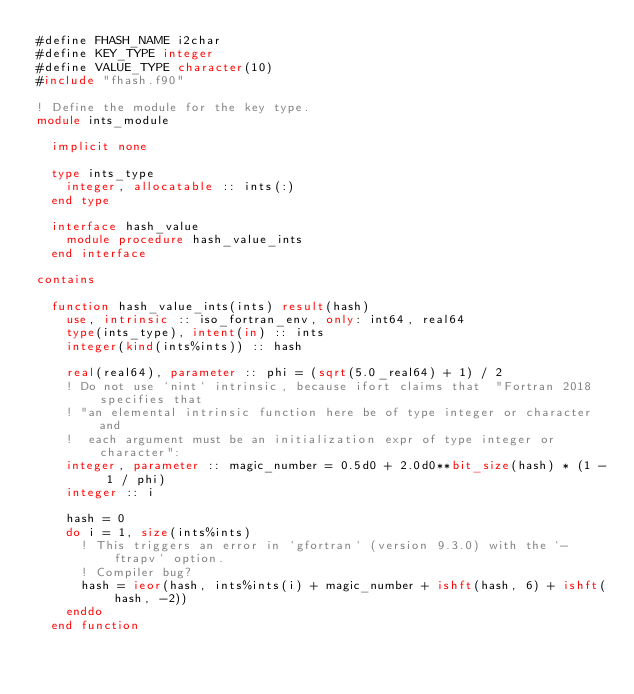<code> <loc_0><loc_0><loc_500><loc_500><_FORTRAN_>#define FHASH_NAME i2char
#define KEY_TYPE integer
#define VALUE_TYPE character(10)
#include "fhash.f90"

! Define the module for the key type.
module ints_module

  implicit none

  type ints_type
    integer, allocatable :: ints(:)
  end type

  interface hash_value
    module procedure hash_value_ints
  end interface

contains

  function hash_value_ints(ints) result(hash)
    use, intrinsic :: iso_fortran_env, only: int64, real64
    type(ints_type), intent(in) :: ints
    integer(kind(ints%ints)) :: hash

    real(real64), parameter :: phi = (sqrt(5.0_real64) + 1) / 2
    ! Do not use `nint` intrinsic, because ifort claims that  "Fortran 2018 specifies that
    ! "an elemental intrinsic function here be of type integer or character and
    !  each argument must be an initialization expr of type integer or character":
    integer, parameter :: magic_number = 0.5d0 + 2.0d0**bit_size(hash) * (1 - 1 / phi)
    integer :: i

    hash = 0
    do i = 1, size(ints%ints)
      ! This triggers an error in `gfortran` (version 9.3.0) with the `-ftrapv` option.
      ! Compiler bug?
      hash = ieor(hash, ints%ints(i) + magic_number + ishft(hash, 6) + ishft(hash, -2))
    enddo
  end function
</code> 